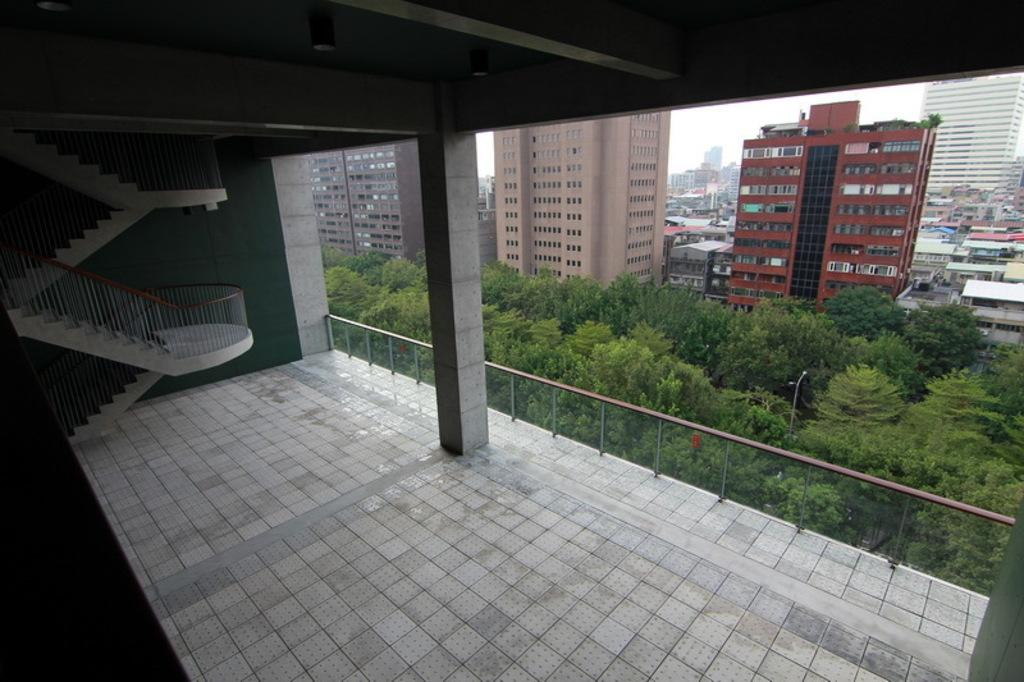What structure is located on the left side of the image? There is a staircase on the left side of the image. What type of wall can be seen in the middle of the image? There is a glass wall in the middle of the image. What type of vegetation is visible in the image? There are trees in the image. What can be seen in the background of the image? There are buildings visible at the top of the image. What type of berry is growing on the staircase in the image? There are no berries present in the image, and the staircase is not a location where berries would typically grow. 